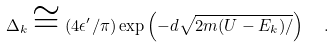Convert formula to latex. <formula><loc_0><loc_0><loc_500><loc_500>\Delta _ { k } \cong ( 4 \epsilon ^ { \prime } / \pi ) \exp \left ( - d \sqrt { 2 m ( U - E _ { k } ) / } \right ) \ \ .</formula> 